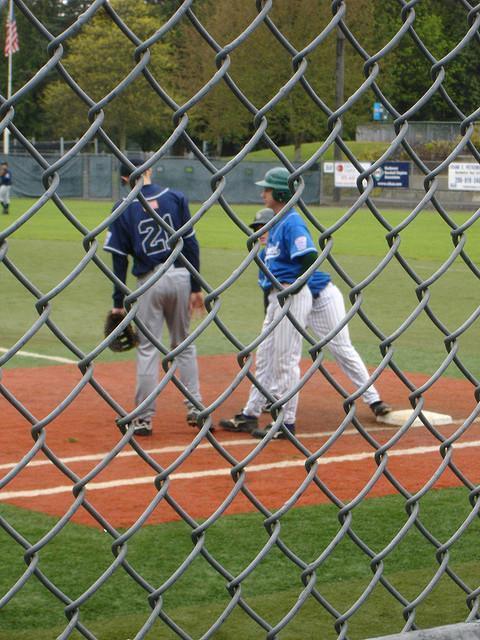How many people can be seen?
Give a very brief answer. 3. 